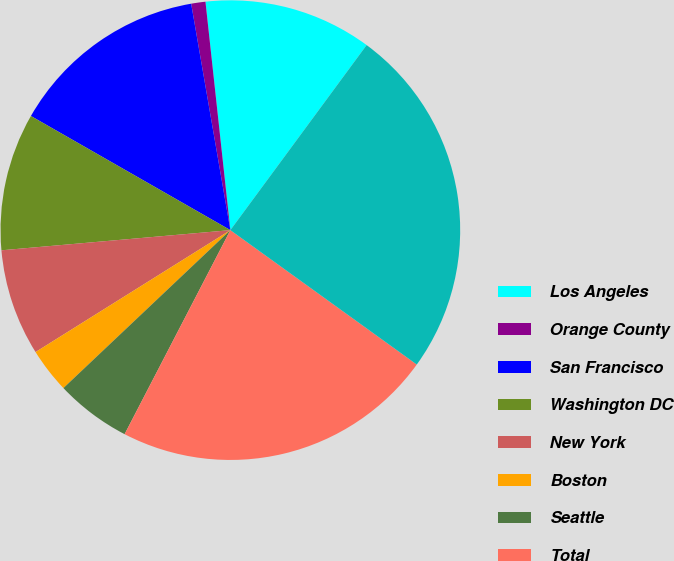Convert chart. <chart><loc_0><loc_0><loc_500><loc_500><pie_chart><fcel>Los Angeles<fcel>Orange County<fcel>San Francisco<fcel>Washington DC<fcel>New York<fcel>Boston<fcel>Seattle<fcel>Total<fcel>Grand Total<nl><fcel>11.83%<fcel>1.0%<fcel>14.0%<fcel>9.67%<fcel>7.5%<fcel>3.16%<fcel>5.33%<fcel>22.67%<fcel>24.84%<nl></chart> 